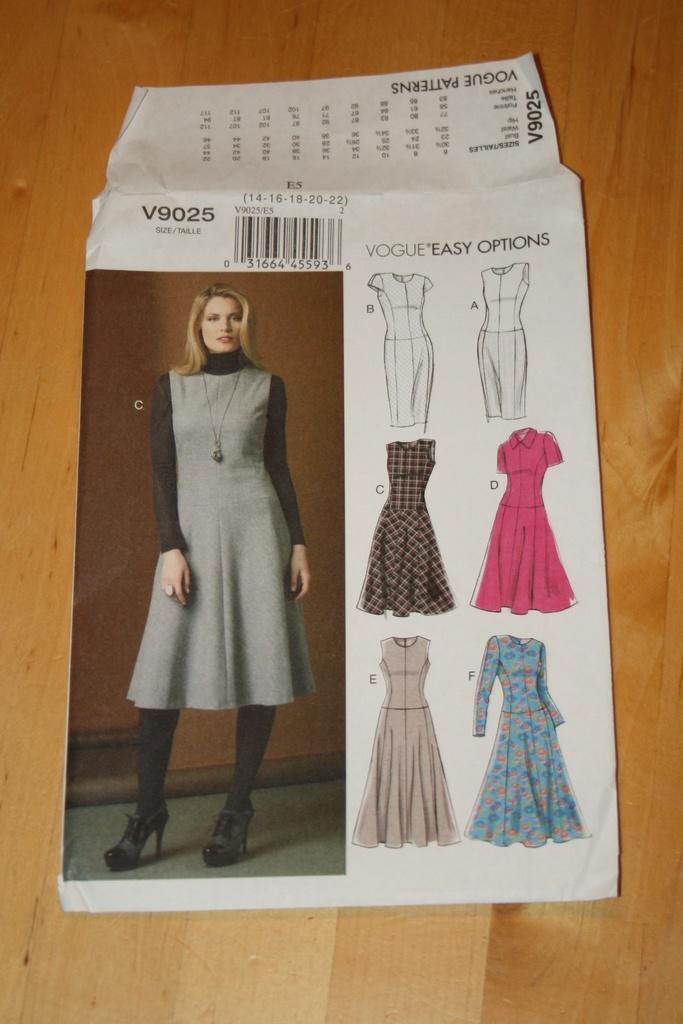Could you give a brief overview of what you see in this image? In this image we can see a poster. On poster we can see a person, few dresses and some text on it. There is a wooden object below the poster. 